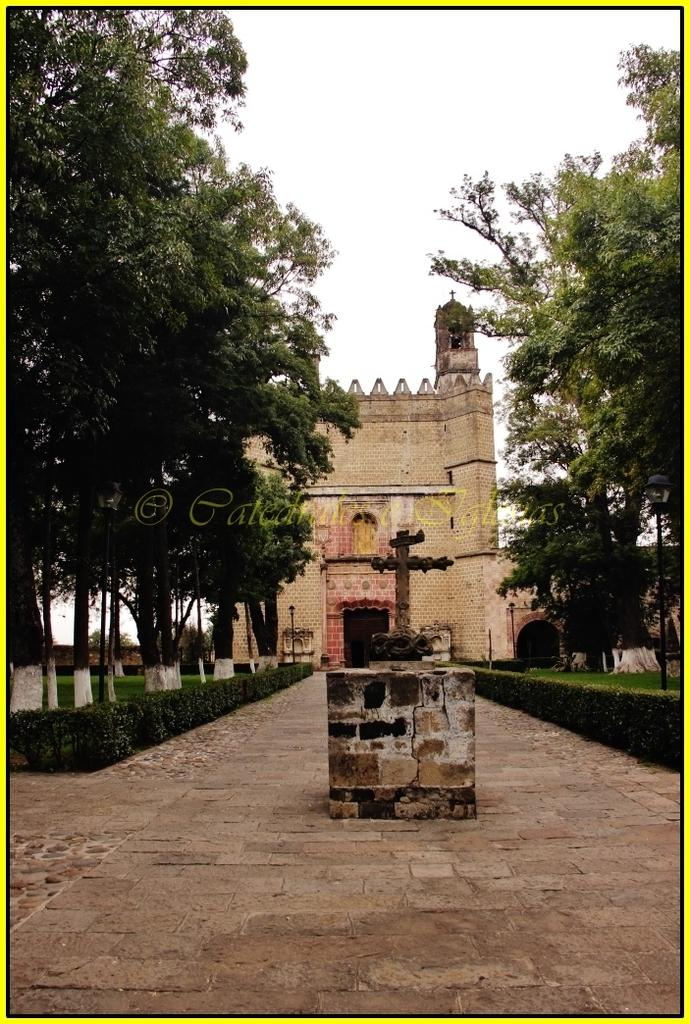What type of structure is visible in the image? There is a building in the image. What other natural elements can be seen in the image? There are trees and plants visible in the image. How would you describe the weather in the image? The sky is cloudy in the image, suggesting a potentially overcast or rainy day. Can you identify any additional features in the image? Yes, there is a statue on a stone in the image. How many visitors can be seen interacting with the statue in the image? There are no visitors present in the image; only the statue, building, trees, plants, and cloudy sky can be seen. Is there a snake visible in the image? No, there is no snake present in the image. 